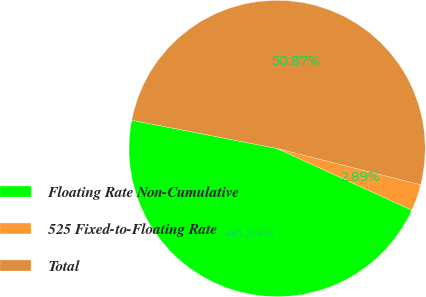Convert chart to OTSL. <chart><loc_0><loc_0><loc_500><loc_500><pie_chart><fcel>Floating Rate Non-Cumulative<fcel>525 Fixed-to-Floating Rate<fcel>Total<nl><fcel>46.24%<fcel>2.89%<fcel>50.87%<nl></chart> 